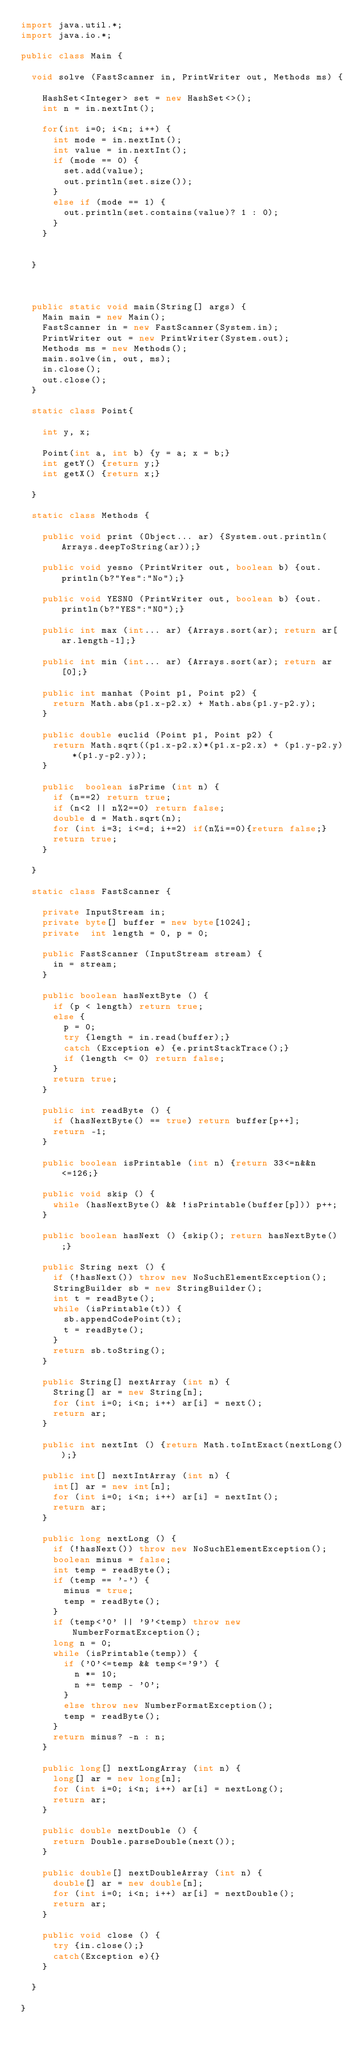Convert code to text. <code><loc_0><loc_0><loc_500><loc_500><_Java_>import java.util.*;
import java.io.*;

public class Main {

	void solve (FastScanner in, PrintWriter out, Methods ms) {

		HashSet<Integer> set = new HashSet<>();
		int n = in.nextInt();
		
		for(int i=0; i<n; i++) {
			int mode = in.nextInt();
			int value = in.nextInt();
			if (mode == 0) {
				set.add(value);
				out.println(set.size());
			}
			else if (mode == 1) {
				out.println(set.contains(value)? 1 : 0);
			}
		}
		

	}



	public static void main(String[] args) {
		Main main = new Main();
		FastScanner in = new FastScanner(System.in);
		PrintWriter out = new PrintWriter(System.out);
		Methods ms = new Methods();
		main.solve(in, out, ms);
		in.close();
		out.close();
	}

	static class Point{

		int y, x;

		Point(int a, int b) {y = a; x = b;}
		int getY() {return y;}
		int getX() {return x;}

	}

	static class Methods {

		public void print (Object... ar) {System.out.println(Arrays.deepToString(ar));}

		public void yesno (PrintWriter out, boolean b) {out.println(b?"Yes":"No");}

		public void YESNO (PrintWriter out, boolean b) {out.println(b?"YES":"NO");}

		public int max (int... ar) {Arrays.sort(ar); return ar[ar.length-1];}

		public int min (int... ar) {Arrays.sort(ar); return ar[0];}

		public int manhat (Point p1, Point p2) {
			return Math.abs(p1.x-p2.x) + Math.abs(p1.y-p2.y);
		}

		public double euclid (Point p1, Point p2) {
			return Math.sqrt((p1.x-p2.x)*(p1.x-p2.x) + (p1.y-p2.y)*(p1.y-p2.y));
		}

		public  boolean isPrime (int n) {
			if (n==2) return true;
			if (n<2 || n%2==0) return false;
			double d = Math.sqrt(n);
			for (int i=3; i<=d; i+=2) if(n%i==0){return false;}
			return true;
		}

	}

	static class FastScanner {

		private InputStream in;
		private byte[] buffer = new byte[1024];
		private  int length = 0, p = 0;

		public FastScanner (InputStream stream) {
			in = stream;
		}

		public boolean hasNextByte () {
			if (p < length) return true;
			else {
				p = 0;
				try {length = in.read(buffer);}
				catch (Exception e) {e.printStackTrace();}
				if (length <= 0) return false;
			}
			return true;
		}

		public int readByte () {
			if (hasNextByte() == true) return buffer[p++];
			return -1;
		}

		public boolean isPrintable (int n) {return 33<=n&&n<=126;}

		public void skip () {
			while (hasNextByte() && !isPrintable(buffer[p])) p++;
		}

		public boolean hasNext () {skip(); return hasNextByte();}

		public String next () {
			if (!hasNext()) throw new NoSuchElementException();
			StringBuilder sb = new StringBuilder();
			int t = readByte();
			while (isPrintable(t)) {
				sb.appendCodePoint(t);
				t = readByte();
			}
			return sb.toString();
		}

		public String[] nextArray (int n) {
			String[] ar = new String[n];
			for (int i=0; i<n; i++) ar[i] = next();
			return ar;
		}

		public int nextInt () {return Math.toIntExact(nextLong());}

		public int[] nextIntArray (int n) {
			int[] ar = new int[n];
			for (int i=0; i<n; i++) ar[i] = nextInt();
			return ar;
		}

		public long nextLong () {
			if (!hasNext()) throw new NoSuchElementException();
			boolean minus = false;
			int temp = readByte();
			if (temp == '-') {
				minus = true;
				temp = readByte();
			}
			if (temp<'0' || '9'<temp) throw new NumberFormatException();
			long n = 0;
			while (isPrintable(temp)) {
				if ('0'<=temp && temp<='9') {
					n *= 10;
					n += temp - '0';
				}
				else throw new NumberFormatException();
				temp = readByte();
			}
			return minus? -n : n;
		}

		public long[] nextLongArray (int n) {
			long[] ar = new long[n];
			for (int i=0; i<n; i++) ar[i] = nextLong();
			return ar;
		}

		public double nextDouble () {
			return Double.parseDouble(next());
		}

		public double[] nextDoubleArray (int n) {
			double[] ar = new double[n];
			for (int i=0; i<n; i++) ar[i] = nextDouble();
			return ar;
		}

		public void close () {
			try {in.close();}
			catch(Exception e){}
		}

	}

}
</code> 